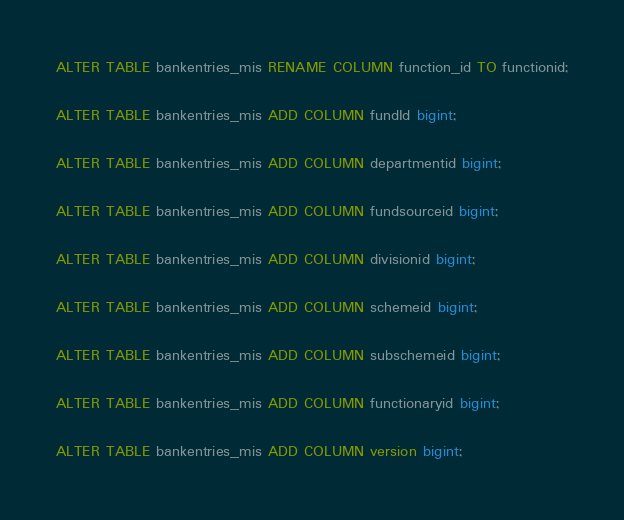Convert code to text. <code><loc_0><loc_0><loc_500><loc_500><_SQL_>
ALTER TABLE bankentries_mis RENAME COLUMN function_id TO functionid;

ALTER TABLE bankentries_mis ADD COLUMN fundId bigint;

ALTER TABLE bankentries_mis ADD COLUMN departmentid bigint;

ALTER TABLE bankentries_mis ADD COLUMN fundsourceid bigint;

ALTER TABLE bankentries_mis ADD COLUMN divisionid bigint;

ALTER TABLE bankentries_mis ADD COLUMN schemeid bigint;

ALTER TABLE bankentries_mis ADD COLUMN subschemeid bigint;

ALTER TABLE bankentries_mis ADD COLUMN functionaryid bigint;

ALTER TABLE bankentries_mis ADD COLUMN version bigint;
</code> 